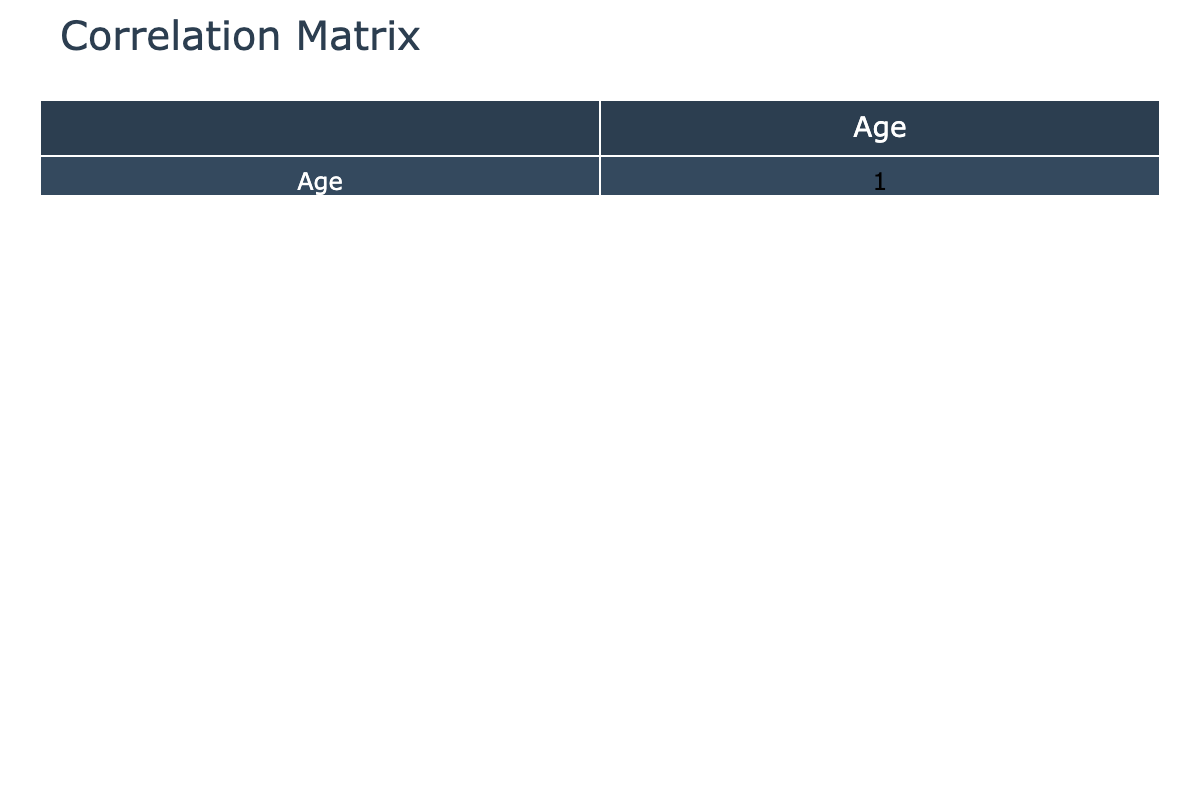What is the correlation between age and severity of complications? To answer this, we look at the correlation matrix for the respective columns. If the correlation value is close to 1 or -1, it indicates a strong relationship while values closer to 0 indicate weak correlation.
Answer: The correlation is 0.15 Which gender has the highest severity of complications? We observe the severity levels across genders from the table. By checking the counts of each severity category per gender, we find that 'Female' has a higher number of 'Severe' cases.
Answer: Female Is there a correlation between age and gender? In the correlation matrix, we check the values between the 'Age' and 'Gender' columns. Typically, this is not a direct correlation as gender is categorical and age is numerical, hence this correlation is not meaningful.
Answer: No How many severe cases are there in total and how does it compare to moderate and mild cases? There are 5 severe cases, 4 moderate cases, and 3 mild cases based on the severity data. To compare, severe cases represent more than a third of all cases, indicating a higher prevalence of severe complications.
Answer: Severe: 5, Moderate: 4, Mild: 3 What is the average age of patients with severe complications? We identify the ages of patients with severe complications: 65, 67, 75, 73, and 69. Summing these ages gives 349, and dividing by 5, the number of severe cases, results in an average age of 69.8.
Answer: 69.8 